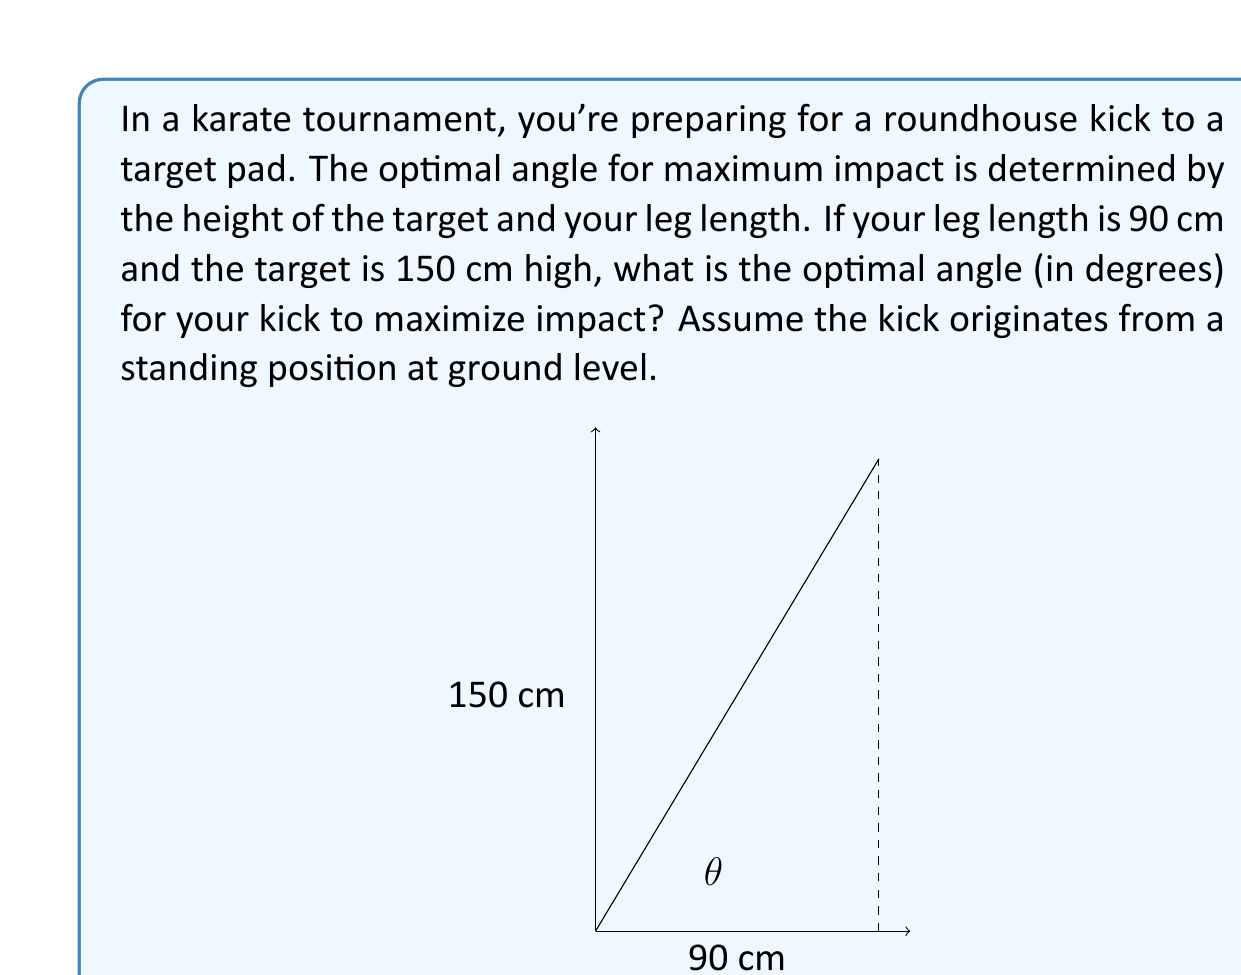Teach me how to tackle this problem. To solve this problem, we'll use trigonometry. Let's break it down step-by-step:

1) In this scenario, we have a right triangle where:
   - The adjacent side is your leg length (90 cm)
   - The opposite side is the target height (150 cm)
   - The hypotenuse is your leg as it strikes the target
   - The angle we're looking for is between your leg and the ground

2) To find the optimal angle for maximum impact, we need to calculate the angle that allows your leg to strike the target perpendicularly. This occurs when your leg forms the hypotenuse of the right triangle.

3) We can use the tangent function to find this angle:

   $$\tan(\theta) = \frac{\text{opposite}}{\text{adjacent}} = \frac{150}{90}$$

4) To solve for $\theta$, we use the inverse tangent (arctangent) function:

   $$\theta = \arctan(\frac{150}{90})$$

5) Using a calculator or computer:

   $$\theta \approx 59.04^{\circ}$$

6) Round to the nearest degree:

   $$\theta \approx 59^{\circ}$$

This angle will ensure that your leg is perpendicular to the target at the moment of impact, maximizing the force transferred and minimizing energy lost to glancing blows.
Answer: The optimal angle for the karate kick to maximize impact is approximately 59°. 